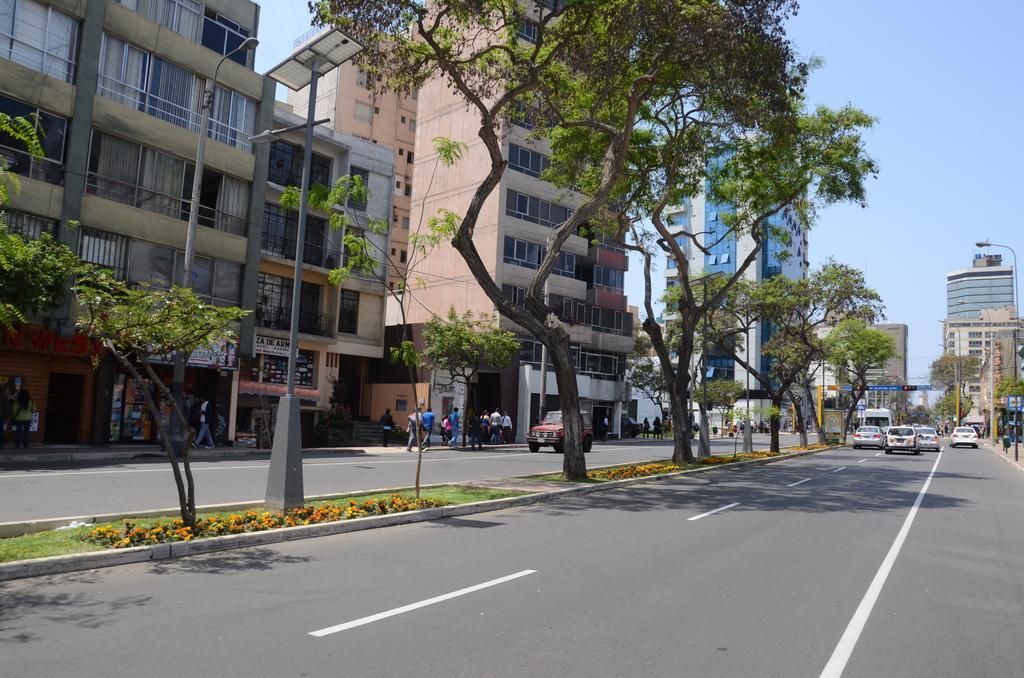Can you describe this image briefly? Here there are vehicles on the road to the either side of the trees. In the background there are buildings,poles,street lights,few persons walking and few are standing on the road,windows,curtains,hoardings,some other items and sky. 